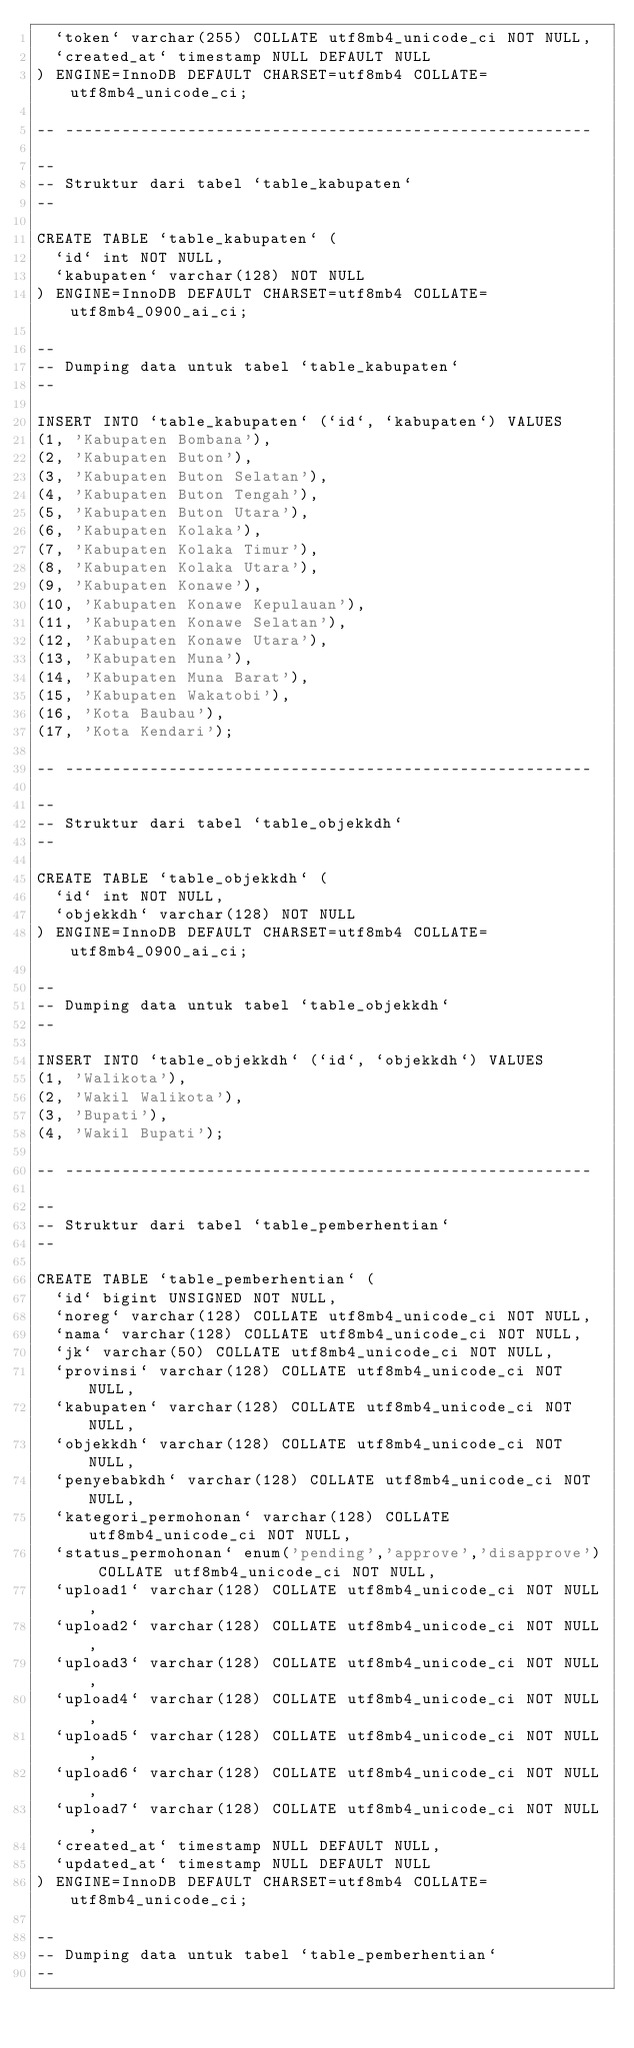Convert code to text. <code><loc_0><loc_0><loc_500><loc_500><_SQL_>  `token` varchar(255) COLLATE utf8mb4_unicode_ci NOT NULL,
  `created_at` timestamp NULL DEFAULT NULL
) ENGINE=InnoDB DEFAULT CHARSET=utf8mb4 COLLATE=utf8mb4_unicode_ci;

-- --------------------------------------------------------

--
-- Struktur dari tabel `table_kabupaten`
--

CREATE TABLE `table_kabupaten` (
  `id` int NOT NULL,
  `kabupaten` varchar(128) NOT NULL
) ENGINE=InnoDB DEFAULT CHARSET=utf8mb4 COLLATE=utf8mb4_0900_ai_ci;

--
-- Dumping data untuk tabel `table_kabupaten`
--

INSERT INTO `table_kabupaten` (`id`, `kabupaten`) VALUES
(1, 'Kabupaten Bombana'),
(2, 'Kabupaten Buton'),
(3, 'Kabupaten Buton Selatan'),
(4, 'Kabupaten Buton Tengah'),
(5, 'Kabupaten Buton Utara'),
(6, 'Kabupaten Kolaka'),
(7, 'Kabupaten Kolaka Timur'),
(8, 'Kabupaten Kolaka Utara'),
(9, 'Kabupaten Konawe'),
(10, 'Kabupaten Konawe Kepulauan'),
(11, 'Kabupaten Konawe Selatan'),
(12, 'Kabupaten Konawe Utara'),
(13, 'Kabupaten Muna'),
(14, 'Kabupaten Muna Barat'),
(15, 'Kabupaten Wakatobi'),
(16, 'Kota Baubau'),
(17, 'Kota Kendari');

-- --------------------------------------------------------

--
-- Struktur dari tabel `table_objekkdh`
--

CREATE TABLE `table_objekkdh` (
  `id` int NOT NULL,
  `objekkdh` varchar(128) NOT NULL
) ENGINE=InnoDB DEFAULT CHARSET=utf8mb4 COLLATE=utf8mb4_0900_ai_ci;

--
-- Dumping data untuk tabel `table_objekkdh`
--

INSERT INTO `table_objekkdh` (`id`, `objekkdh`) VALUES
(1, 'Walikota'),
(2, 'Wakil Walikota'),
(3, 'Bupati'),
(4, 'Wakil Bupati');

-- --------------------------------------------------------

--
-- Struktur dari tabel `table_pemberhentian`
--

CREATE TABLE `table_pemberhentian` (
  `id` bigint UNSIGNED NOT NULL,
  `noreg` varchar(128) COLLATE utf8mb4_unicode_ci NOT NULL,
  `nama` varchar(128) COLLATE utf8mb4_unicode_ci NOT NULL,
  `jk` varchar(50) COLLATE utf8mb4_unicode_ci NOT NULL,
  `provinsi` varchar(128) COLLATE utf8mb4_unicode_ci NOT NULL,
  `kabupaten` varchar(128) COLLATE utf8mb4_unicode_ci NOT NULL,
  `objekkdh` varchar(128) COLLATE utf8mb4_unicode_ci NOT NULL,
  `penyebabkdh` varchar(128) COLLATE utf8mb4_unicode_ci NOT NULL,
  `kategori_permohonan` varchar(128) COLLATE utf8mb4_unicode_ci NOT NULL,
  `status_permohonan` enum('pending','approve','disapprove') COLLATE utf8mb4_unicode_ci NOT NULL,
  `upload1` varchar(128) COLLATE utf8mb4_unicode_ci NOT NULL,
  `upload2` varchar(128) COLLATE utf8mb4_unicode_ci NOT NULL,
  `upload3` varchar(128) COLLATE utf8mb4_unicode_ci NOT NULL,
  `upload4` varchar(128) COLLATE utf8mb4_unicode_ci NOT NULL,
  `upload5` varchar(128) COLLATE utf8mb4_unicode_ci NOT NULL,
  `upload6` varchar(128) COLLATE utf8mb4_unicode_ci NOT NULL,
  `upload7` varchar(128) COLLATE utf8mb4_unicode_ci NOT NULL,
  `created_at` timestamp NULL DEFAULT NULL,
  `updated_at` timestamp NULL DEFAULT NULL
) ENGINE=InnoDB DEFAULT CHARSET=utf8mb4 COLLATE=utf8mb4_unicode_ci;

--
-- Dumping data untuk tabel `table_pemberhentian`
--
</code> 